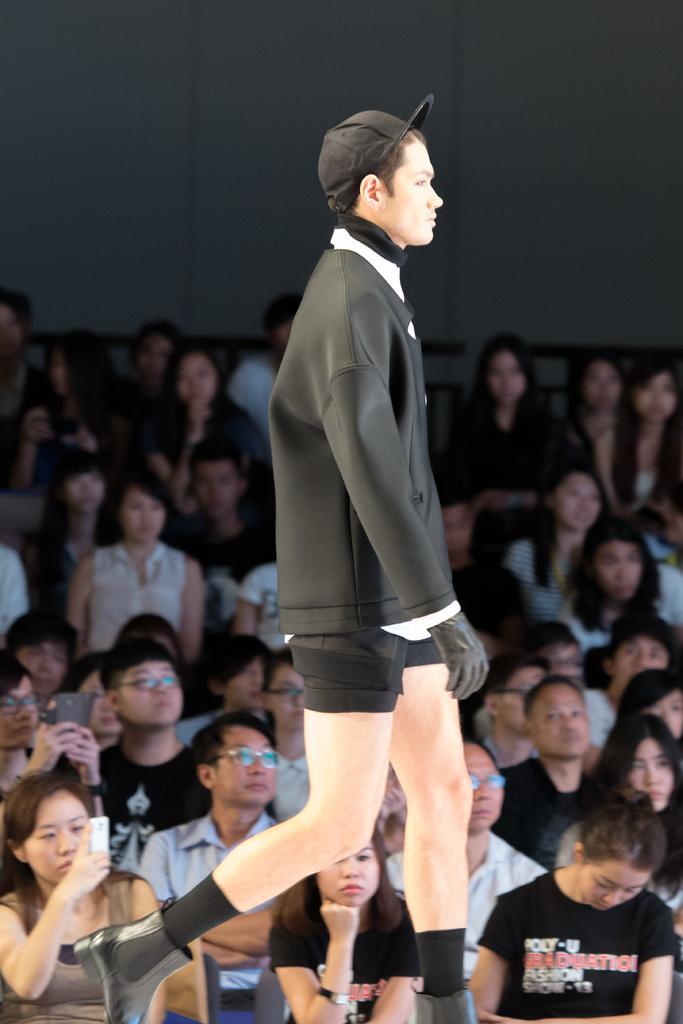Please provide a concise description of this image. Here I can see a man wearing a black color jacket and walking on the stage towards the right side. In the background there are many people sitting and looking at this man. 